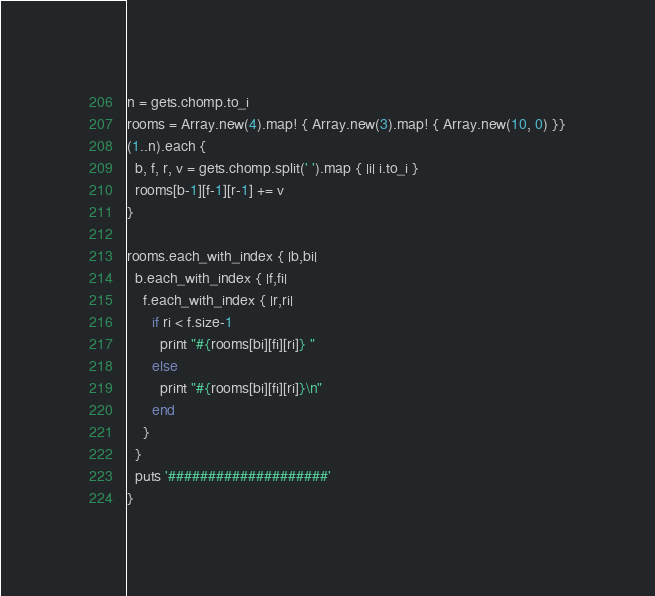Convert code to text. <code><loc_0><loc_0><loc_500><loc_500><_Ruby_>n = gets.chomp.to_i
rooms = Array.new(4).map! { Array.new(3).map! { Array.new(10, 0) }}
(1..n).each {
  b, f, r, v = gets.chomp.split(' ').map { |i| i.to_i }
  rooms[b-1][f-1][r-1] += v
}

rooms.each_with_index { |b,bi|
  b.each_with_index { |f,fi|
    f.each_with_index { |r,ri|
      if ri < f.size-1
        print "#{rooms[bi][fi][ri]} "
      else
        print "#{rooms[bi][fi][ri]}\n"
      end
    }
  }
  puts '####################'
}</code> 